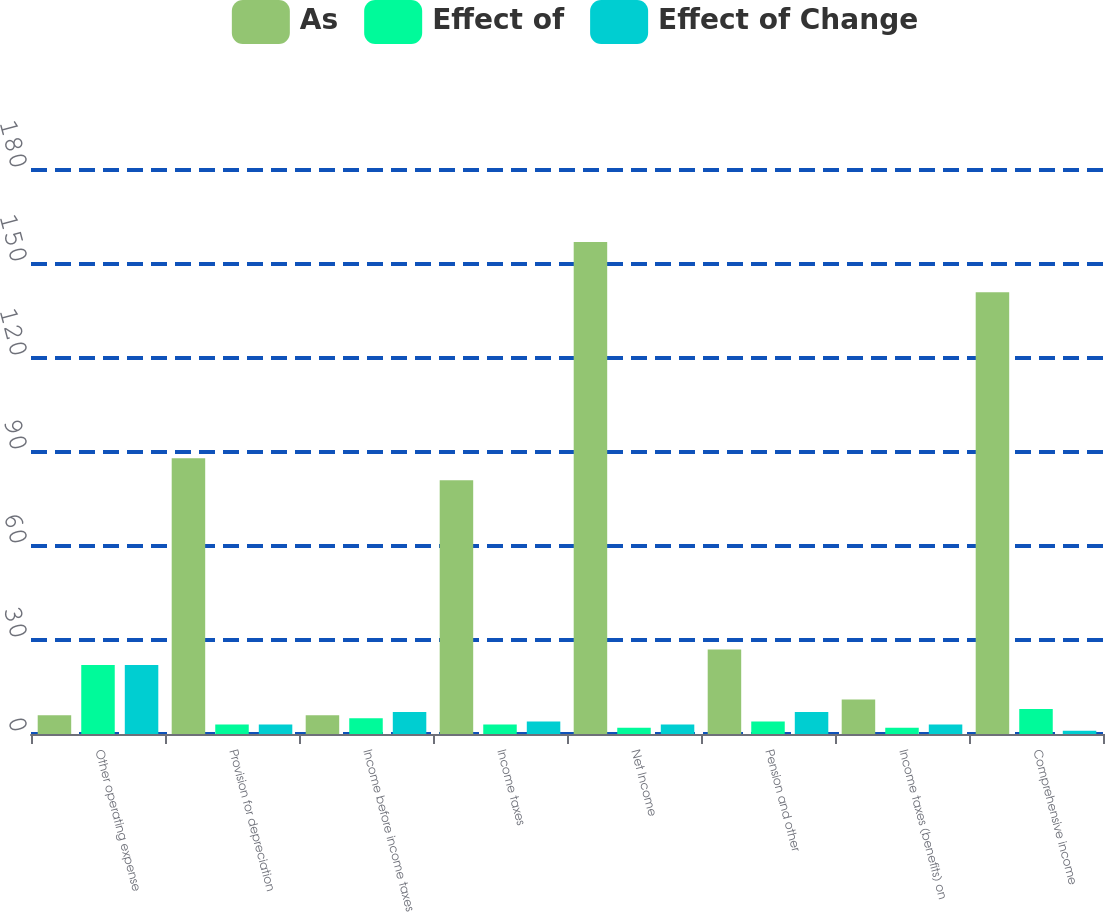Convert chart. <chart><loc_0><loc_0><loc_500><loc_500><stacked_bar_chart><ecel><fcel>Other operating expense<fcel>Provision for depreciation<fcel>Income before income taxes<fcel>Income taxes<fcel>Net Income<fcel>Pension and other<fcel>Income taxes (benefits) on<fcel>Comprehensive income<nl><fcel>As<fcel>6<fcel>88<fcel>6<fcel>81<fcel>157<fcel>27<fcel>11<fcel>141<nl><fcel>Effect of<fcel>22<fcel>3<fcel>5<fcel>3<fcel>2<fcel>4<fcel>2<fcel>8<nl><fcel>Effect of Change<fcel>22<fcel>3<fcel>7<fcel>4<fcel>3<fcel>7<fcel>3<fcel>1<nl></chart> 